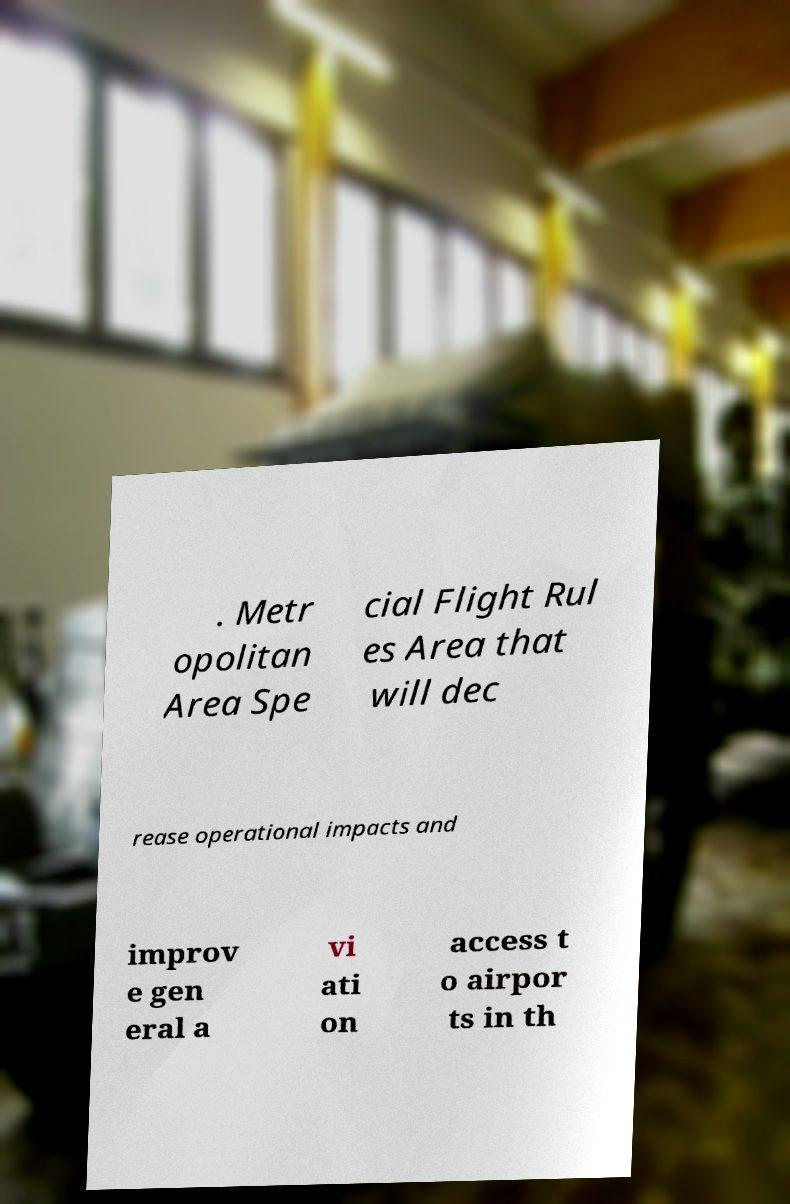For documentation purposes, I need the text within this image transcribed. Could you provide that? . Metr opolitan Area Spe cial Flight Rul es Area that will dec rease operational impacts and improv e gen eral a vi ati on access t o airpor ts in th 